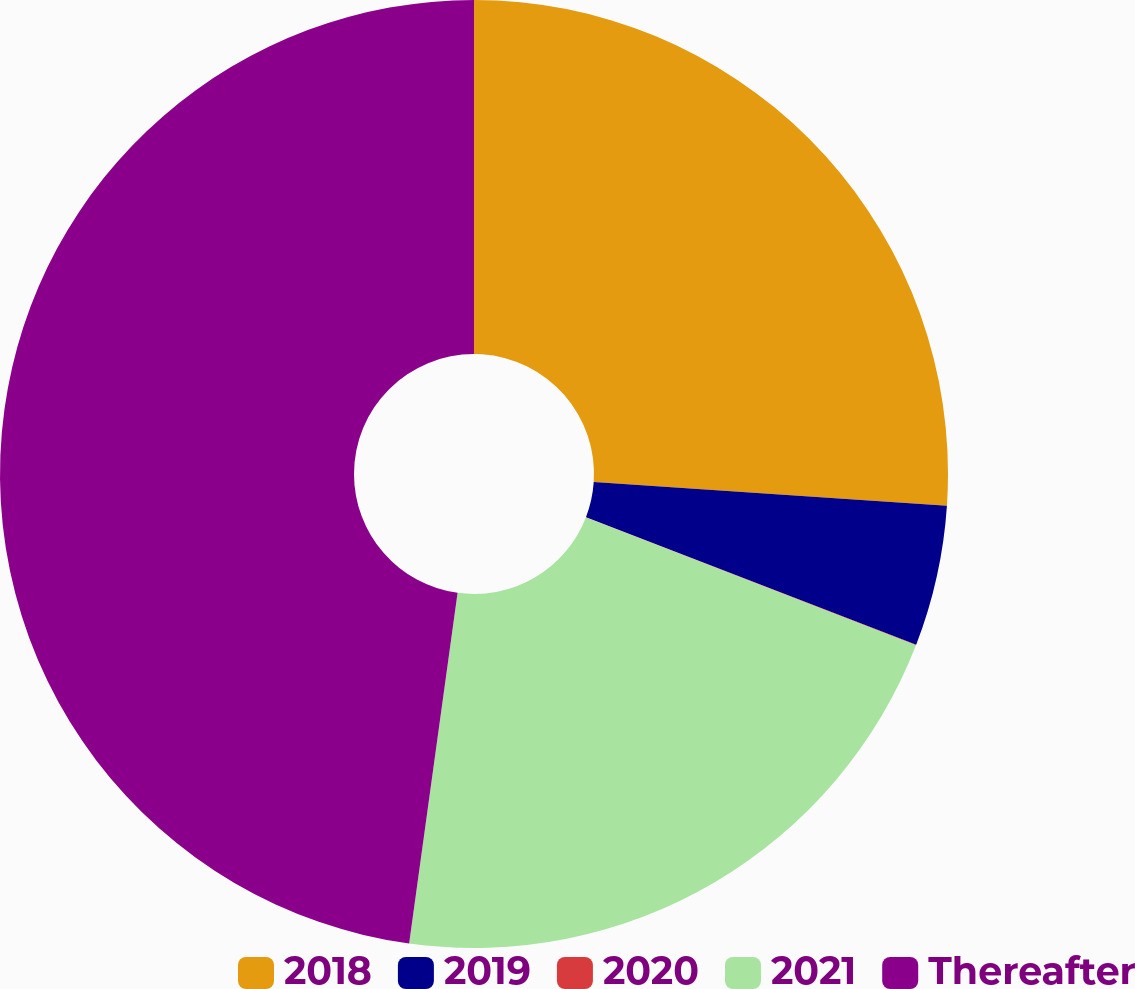Convert chart to OTSL. <chart><loc_0><loc_0><loc_500><loc_500><pie_chart><fcel>2018<fcel>2019<fcel>2020<fcel>2021<fcel>Thereafter<nl><fcel>26.07%<fcel>4.8%<fcel>0.02%<fcel>21.3%<fcel>47.82%<nl></chart> 